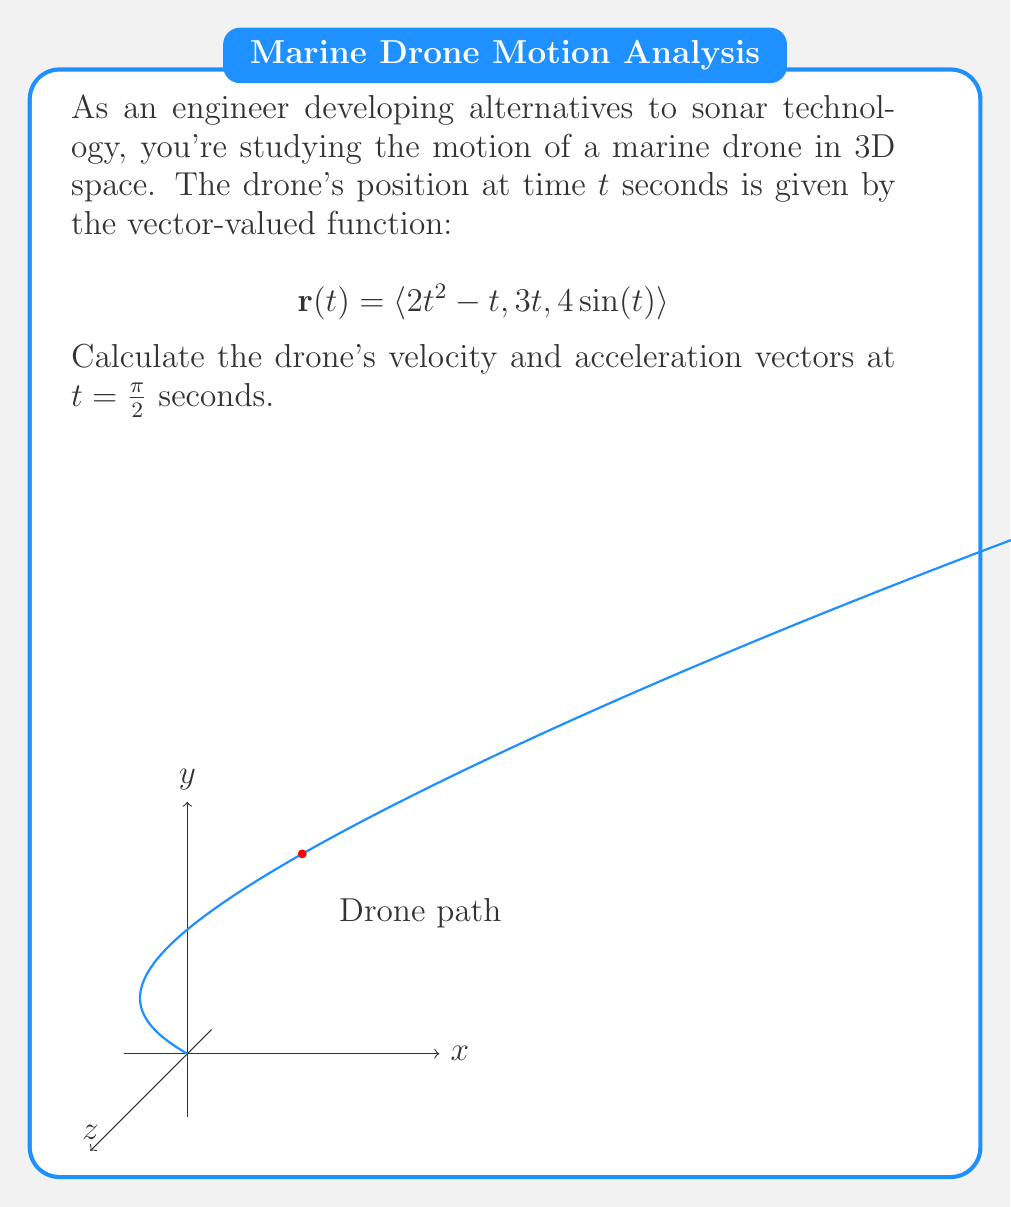Can you answer this question? To solve this problem, we need to follow these steps:

1) Velocity vector:
   The velocity vector is the first derivative of the position vector:
   $$\mathbf{v}(t) = \frac{d}{dt}\mathbf{r}(t) = \langle \frac{d}{dt}(2t^2 - t), \frac{d}{dt}(3t), \frac{d}{dt}(4 \sin(t)) \rangle$$
   $$\mathbf{v}(t) = \langle 4t - 1, 3, 4 \cos(t) \rangle$$

2) Acceleration vector:
   The acceleration vector is the second derivative of the position vector or the first derivative of the velocity vector:
   $$\mathbf{a}(t) = \frac{d}{dt}\mathbf{v}(t) = \langle \frac{d}{dt}(4t - 1), \frac{d}{dt}(3), \frac{d}{dt}(4 \cos(t)) \rangle$$
   $$\mathbf{a}(t) = \langle 4, 0, -4 \sin(t) \rangle$$

3) Evaluate at $t = \pi/2$:
   For velocity:
   $$\mathbf{v}(\pi/2) = \langle 4(\pi/2) - 1, 3, 4 \cos(\pi/2) \rangle = \langle 2\pi - 1, 3, 0 \rangle$$

   For acceleration:
   $$\mathbf{a}(\pi/2) = \langle 4, 0, -4 \sin(\pi/2) \rangle = \langle 4, 0, -4 \rangle$$

Therefore, at $t = \pi/2$ seconds:
- The velocity vector is $\langle 2\pi - 1, 3, 0 \rangle$
- The acceleration vector is $\langle 4, 0, -4 \rangle$
Answer: $\mathbf{v}(\pi/2) = \langle 2\pi - 1, 3, 0 \rangle$, $\mathbf{a}(\pi/2) = \langle 4, 0, -4 \rangle$ 